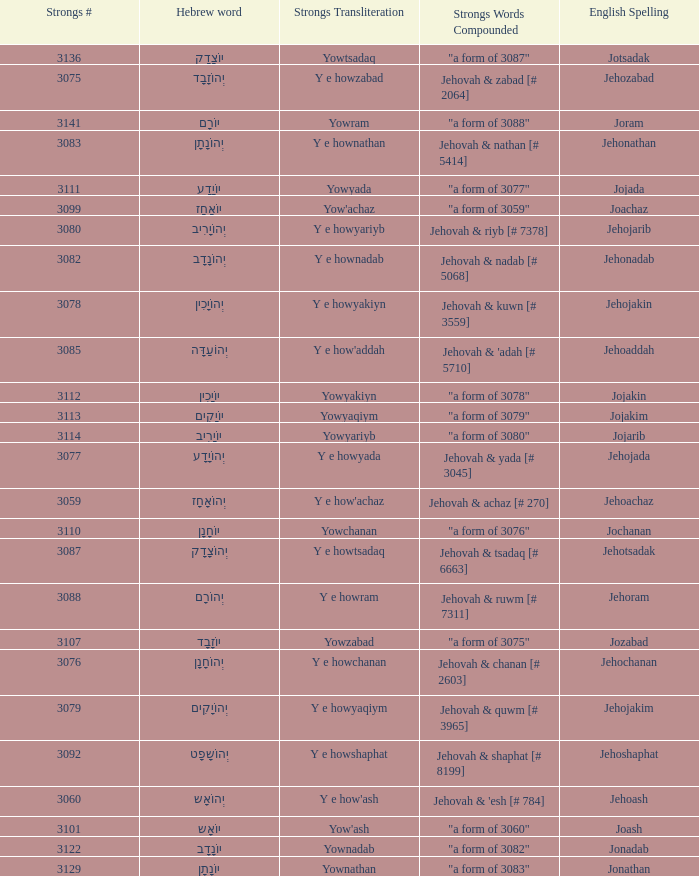What is the strongs transliteration of the hebrew word יוֹחָנָן? Yowchanan. 